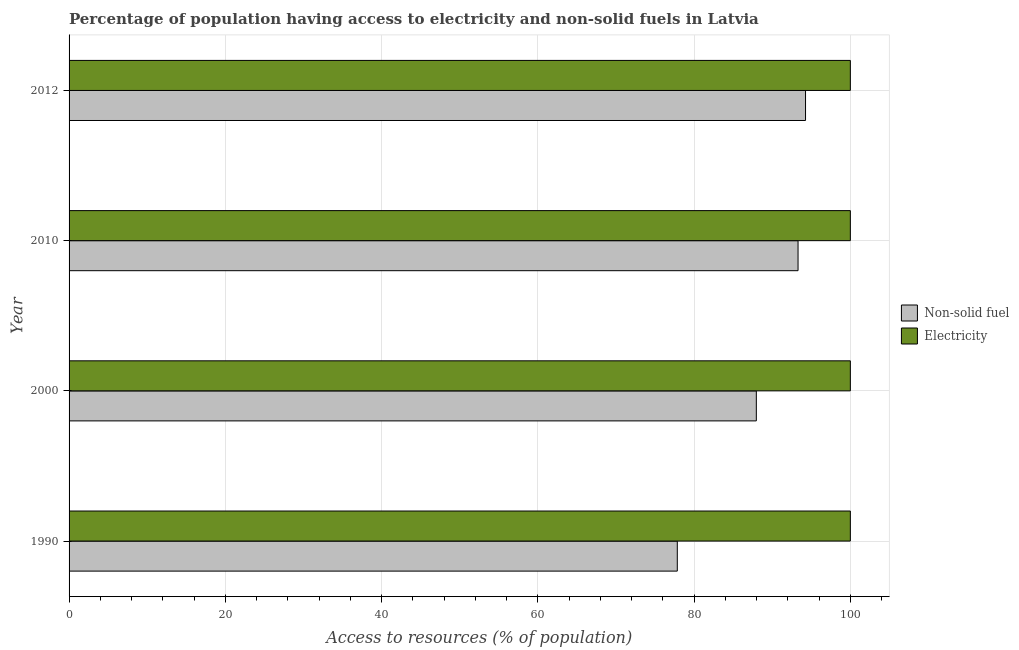Are the number of bars on each tick of the Y-axis equal?
Provide a short and direct response. Yes. In how many cases, is the number of bars for a given year not equal to the number of legend labels?
Provide a succinct answer. 0. What is the percentage of population having access to non-solid fuel in 2000?
Offer a terse response. 87.97. Across all years, what is the maximum percentage of population having access to non-solid fuel?
Provide a succinct answer. 94.26. Across all years, what is the minimum percentage of population having access to non-solid fuel?
Make the answer very short. 77.85. In which year was the percentage of population having access to electricity maximum?
Give a very brief answer. 1990. What is the total percentage of population having access to non-solid fuel in the graph?
Make the answer very short. 353.38. What is the difference between the percentage of population having access to non-solid fuel in 1990 and that in 2012?
Offer a terse response. -16.41. What is the difference between the percentage of population having access to non-solid fuel in 2000 and the percentage of population having access to electricity in 1990?
Give a very brief answer. -12.03. What is the average percentage of population having access to non-solid fuel per year?
Provide a succinct answer. 88.35. In the year 2010, what is the difference between the percentage of population having access to electricity and percentage of population having access to non-solid fuel?
Provide a succinct answer. 6.69. In how many years, is the percentage of population having access to non-solid fuel greater than 36 %?
Offer a very short reply. 4. What is the ratio of the percentage of population having access to non-solid fuel in 1990 to that in 2010?
Provide a short and direct response. 0.83. Is the percentage of population having access to electricity in 2000 less than that in 2012?
Your answer should be very brief. No. Is the difference between the percentage of population having access to non-solid fuel in 1990 and 2010 greater than the difference between the percentage of population having access to electricity in 1990 and 2010?
Provide a short and direct response. No. What is the difference between the highest and the second highest percentage of population having access to electricity?
Keep it short and to the point. 0. What is the difference between the highest and the lowest percentage of population having access to electricity?
Offer a terse response. 0. In how many years, is the percentage of population having access to electricity greater than the average percentage of population having access to electricity taken over all years?
Your answer should be compact. 0. What does the 1st bar from the top in 2010 represents?
Keep it short and to the point. Electricity. What does the 1st bar from the bottom in 1990 represents?
Provide a short and direct response. Non-solid fuel. How many bars are there?
Give a very brief answer. 8. What is the difference between two consecutive major ticks on the X-axis?
Offer a terse response. 20. Are the values on the major ticks of X-axis written in scientific E-notation?
Keep it short and to the point. No. Does the graph contain any zero values?
Offer a very short reply. No. Where does the legend appear in the graph?
Your response must be concise. Center right. How many legend labels are there?
Your answer should be compact. 2. What is the title of the graph?
Your answer should be very brief. Percentage of population having access to electricity and non-solid fuels in Latvia. Does "Lowest 10% of population" appear as one of the legend labels in the graph?
Provide a succinct answer. No. What is the label or title of the X-axis?
Make the answer very short. Access to resources (% of population). What is the label or title of the Y-axis?
Give a very brief answer. Year. What is the Access to resources (% of population) of Non-solid fuel in 1990?
Your response must be concise. 77.85. What is the Access to resources (% of population) in Non-solid fuel in 2000?
Provide a succinct answer. 87.97. What is the Access to resources (% of population) of Non-solid fuel in 2010?
Provide a succinct answer. 93.31. What is the Access to resources (% of population) of Non-solid fuel in 2012?
Make the answer very short. 94.26. Across all years, what is the maximum Access to resources (% of population) in Non-solid fuel?
Your answer should be very brief. 94.26. Across all years, what is the maximum Access to resources (% of population) of Electricity?
Provide a succinct answer. 100. Across all years, what is the minimum Access to resources (% of population) in Non-solid fuel?
Keep it short and to the point. 77.85. Across all years, what is the minimum Access to resources (% of population) in Electricity?
Your response must be concise. 100. What is the total Access to resources (% of population) in Non-solid fuel in the graph?
Provide a succinct answer. 353.38. What is the total Access to resources (% of population) in Electricity in the graph?
Make the answer very short. 400. What is the difference between the Access to resources (% of population) in Non-solid fuel in 1990 and that in 2000?
Provide a short and direct response. -10.12. What is the difference between the Access to resources (% of population) in Electricity in 1990 and that in 2000?
Offer a terse response. 0. What is the difference between the Access to resources (% of population) of Non-solid fuel in 1990 and that in 2010?
Your answer should be very brief. -15.46. What is the difference between the Access to resources (% of population) of Non-solid fuel in 1990 and that in 2012?
Keep it short and to the point. -16.41. What is the difference between the Access to resources (% of population) in Non-solid fuel in 2000 and that in 2010?
Give a very brief answer. -5.34. What is the difference between the Access to resources (% of population) of Electricity in 2000 and that in 2010?
Offer a very short reply. 0. What is the difference between the Access to resources (% of population) of Non-solid fuel in 2000 and that in 2012?
Make the answer very short. -6.3. What is the difference between the Access to resources (% of population) of Non-solid fuel in 2010 and that in 2012?
Your answer should be very brief. -0.96. What is the difference between the Access to resources (% of population) of Electricity in 2010 and that in 2012?
Your answer should be compact. 0. What is the difference between the Access to resources (% of population) in Non-solid fuel in 1990 and the Access to resources (% of population) in Electricity in 2000?
Keep it short and to the point. -22.15. What is the difference between the Access to resources (% of population) in Non-solid fuel in 1990 and the Access to resources (% of population) in Electricity in 2010?
Your answer should be compact. -22.15. What is the difference between the Access to resources (% of population) of Non-solid fuel in 1990 and the Access to resources (% of population) of Electricity in 2012?
Give a very brief answer. -22.15. What is the difference between the Access to resources (% of population) of Non-solid fuel in 2000 and the Access to resources (% of population) of Electricity in 2010?
Keep it short and to the point. -12.03. What is the difference between the Access to resources (% of population) in Non-solid fuel in 2000 and the Access to resources (% of population) in Electricity in 2012?
Offer a very short reply. -12.03. What is the difference between the Access to resources (% of population) in Non-solid fuel in 2010 and the Access to resources (% of population) in Electricity in 2012?
Provide a succinct answer. -6.69. What is the average Access to resources (% of population) of Non-solid fuel per year?
Ensure brevity in your answer.  88.35. In the year 1990, what is the difference between the Access to resources (% of population) in Non-solid fuel and Access to resources (% of population) in Electricity?
Make the answer very short. -22.15. In the year 2000, what is the difference between the Access to resources (% of population) in Non-solid fuel and Access to resources (% of population) in Electricity?
Ensure brevity in your answer.  -12.03. In the year 2010, what is the difference between the Access to resources (% of population) in Non-solid fuel and Access to resources (% of population) in Electricity?
Your answer should be very brief. -6.69. In the year 2012, what is the difference between the Access to resources (% of population) of Non-solid fuel and Access to resources (% of population) of Electricity?
Give a very brief answer. -5.74. What is the ratio of the Access to resources (% of population) of Non-solid fuel in 1990 to that in 2000?
Your answer should be compact. 0.89. What is the ratio of the Access to resources (% of population) of Non-solid fuel in 1990 to that in 2010?
Keep it short and to the point. 0.83. What is the ratio of the Access to resources (% of population) in Non-solid fuel in 1990 to that in 2012?
Provide a succinct answer. 0.83. What is the ratio of the Access to resources (% of population) in Electricity in 1990 to that in 2012?
Your answer should be compact. 1. What is the ratio of the Access to resources (% of population) in Non-solid fuel in 2000 to that in 2010?
Provide a succinct answer. 0.94. What is the ratio of the Access to resources (% of population) of Electricity in 2000 to that in 2010?
Keep it short and to the point. 1. What is the ratio of the Access to resources (% of population) of Non-solid fuel in 2000 to that in 2012?
Your answer should be very brief. 0.93. What is the ratio of the Access to resources (% of population) in Electricity in 2000 to that in 2012?
Provide a succinct answer. 1. What is the difference between the highest and the second highest Access to resources (% of population) in Non-solid fuel?
Provide a succinct answer. 0.96. What is the difference between the highest and the lowest Access to resources (% of population) of Non-solid fuel?
Provide a succinct answer. 16.41. What is the difference between the highest and the lowest Access to resources (% of population) in Electricity?
Provide a short and direct response. 0. 